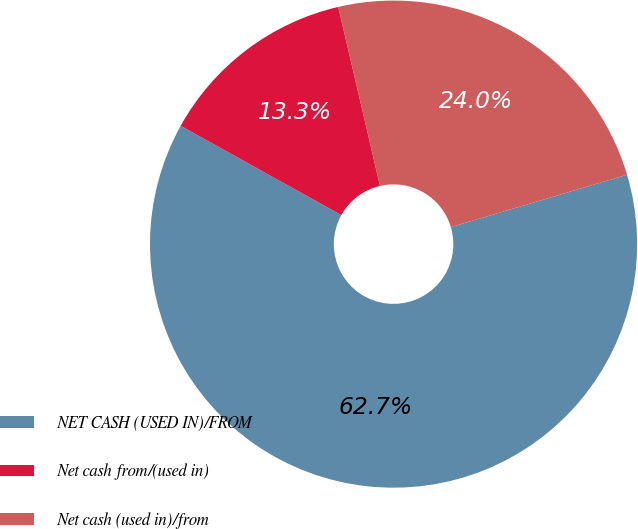<chart> <loc_0><loc_0><loc_500><loc_500><pie_chart><fcel>NET CASH (USED IN)/FROM<fcel>Net cash from/(used in)<fcel>Net cash (used in)/from<nl><fcel>62.67%<fcel>13.28%<fcel>24.05%<nl></chart> 